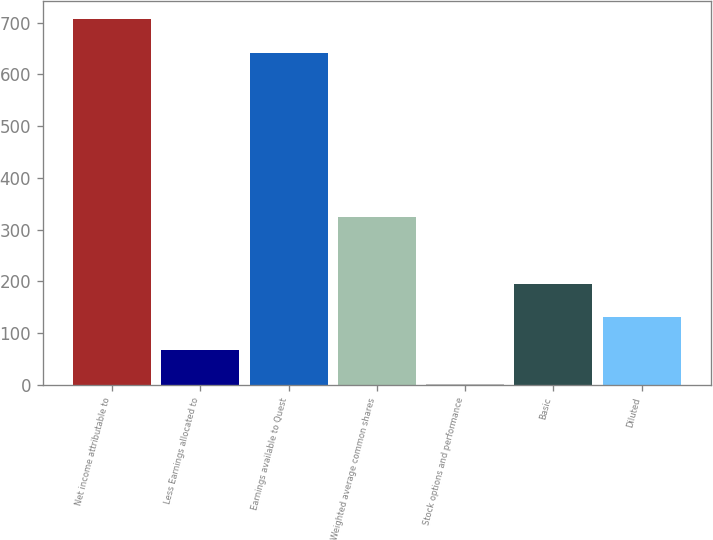<chart> <loc_0><loc_0><loc_500><loc_500><bar_chart><fcel>Net income attributable to<fcel>Less Earnings allocated to<fcel>Earnings available to Quest<fcel>Weighted average common shares<fcel>Stock options and performance<fcel>Basic<fcel>Diluted<nl><fcel>706.3<fcel>66.3<fcel>642<fcel>323.5<fcel>2<fcel>194.9<fcel>130.6<nl></chart> 